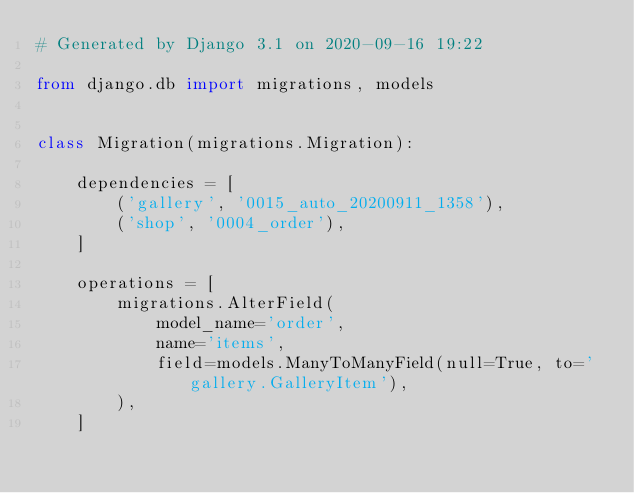Convert code to text. <code><loc_0><loc_0><loc_500><loc_500><_Python_># Generated by Django 3.1 on 2020-09-16 19:22

from django.db import migrations, models


class Migration(migrations.Migration):

    dependencies = [
        ('gallery', '0015_auto_20200911_1358'),
        ('shop', '0004_order'),
    ]

    operations = [
        migrations.AlterField(
            model_name='order',
            name='items',
            field=models.ManyToManyField(null=True, to='gallery.GalleryItem'),
        ),
    ]
</code> 